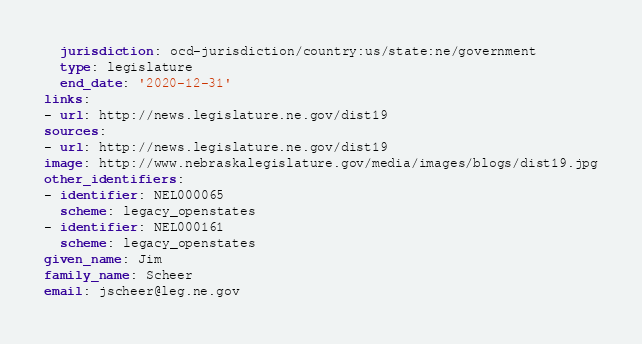Convert code to text. <code><loc_0><loc_0><loc_500><loc_500><_YAML_>  jurisdiction: ocd-jurisdiction/country:us/state:ne/government
  type: legislature
  end_date: '2020-12-31'
links:
- url: http://news.legislature.ne.gov/dist19
sources:
- url: http://news.legislature.ne.gov/dist19
image: http://www.nebraskalegislature.gov/media/images/blogs/dist19.jpg
other_identifiers:
- identifier: NEL000065
  scheme: legacy_openstates
- identifier: NEL000161
  scheme: legacy_openstates
given_name: Jim
family_name: Scheer
email: jscheer@leg.ne.gov
</code> 